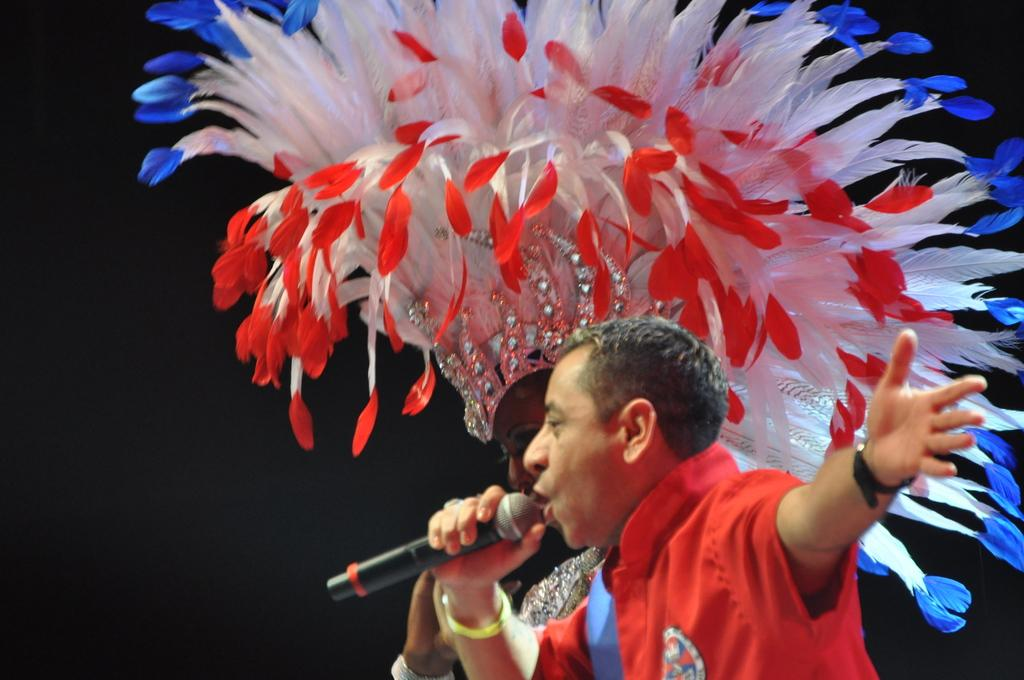Who are the people in the image? There is a man and a woman in the image. What is the man holding in the image? The man is holding a mic. What is the woman wearing in the image? The woman is wearing a costume. What can be observed about the background of the image? The background of the image is dark. What type of building can be seen in the background of the image? There is no building visible in the background of the image; it is dark. How is the woman holding her umbrella in the image? There is no umbrella present in the image. 